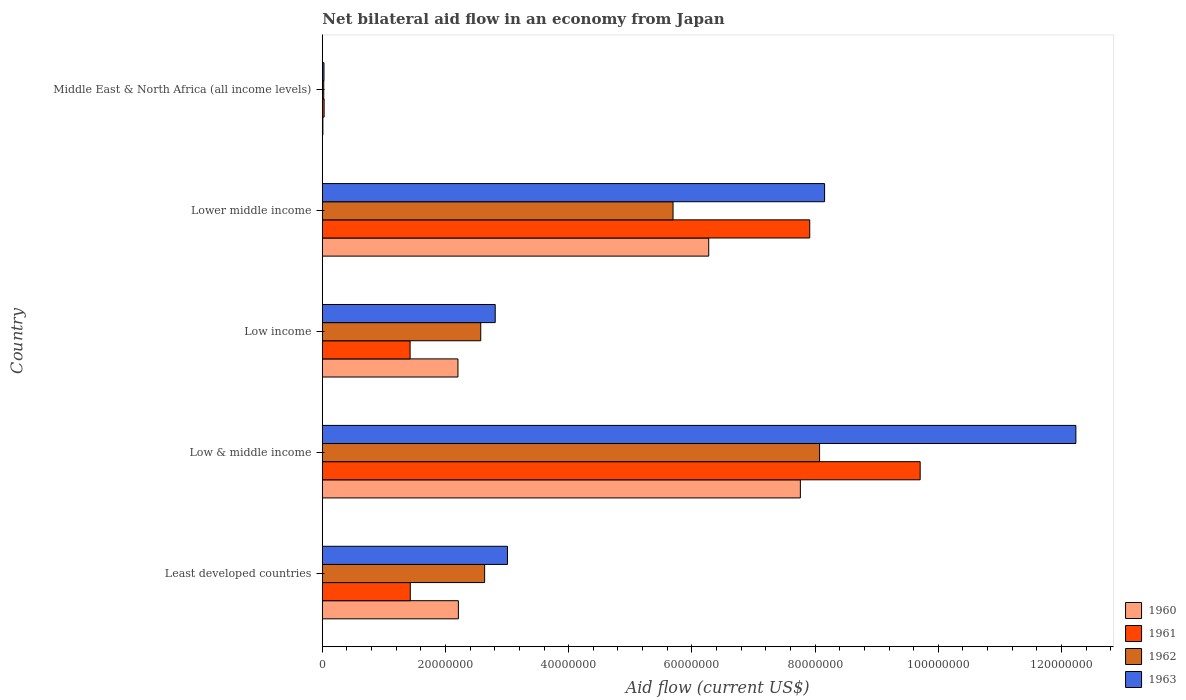How many bars are there on the 4th tick from the top?
Offer a terse response. 4. How many bars are there on the 4th tick from the bottom?
Your response must be concise. 4. What is the label of the 1st group of bars from the top?
Provide a succinct answer. Middle East & North Africa (all income levels). In how many cases, is the number of bars for a given country not equal to the number of legend labels?
Keep it short and to the point. 0. What is the net bilateral aid flow in 1962 in Low & middle income?
Provide a short and direct response. 8.07e+07. Across all countries, what is the maximum net bilateral aid flow in 1960?
Give a very brief answer. 7.76e+07. Across all countries, what is the minimum net bilateral aid flow in 1960?
Make the answer very short. 9.00e+04. In which country was the net bilateral aid flow in 1962 minimum?
Give a very brief answer. Middle East & North Africa (all income levels). What is the total net bilateral aid flow in 1960 in the graph?
Your answer should be very brief. 1.85e+08. What is the difference between the net bilateral aid flow in 1960 in Least developed countries and that in Low & middle income?
Offer a very short reply. -5.55e+07. What is the difference between the net bilateral aid flow in 1961 in Least developed countries and the net bilateral aid flow in 1963 in Low & middle income?
Offer a terse response. -1.08e+08. What is the average net bilateral aid flow in 1960 per country?
Ensure brevity in your answer.  3.69e+07. What is the difference between the net bilateral aid flow in 1963 and net bilateral aid flow in 1960 in Middle East & North Africa (all income levels)?
Your answer should be very brief. 1.80e+05. In how many countries, is the net bilateral aid flow in 1960 greater than 56000000 US$?
Keep it short and to the point. 2. What is the ratio of the net bilateral aid flow in 1960 in Low & middle income to that in Middle East & North Africa (all income levels)?
Offer a terse response. 862.33. Is the net bilateral aid flow in 1962 in Least developed countries less than that in Middle East & North Africa (all income levels)?
Offer a very short reply. No. Is the difference between the net bilateral aid flow in 1963 in Low income and Lower middle income greater than the difference between the net bilateral aid flow in 1960 in Low income and Lower middle income?
Your answer should be very brief. No. What is the difference between the highest and the second highest net bilateral aid flow in 1962?
Your answer should be very brief. 2.38e+07. What is the difference between the highest and the lowest net bilateral aid flow in 1962?
Offer a terse response. 8.05e+07. Is the sum of the net bilateral aid flow in 1961 in Least developed countries and Low income greater than the maximum net bilateral aid flow in 1962 across all countries?
Provide a short and direct response. No. What does the 1st bar from the top in Least developed countries represents?
Your answer should be compact. 1963. What does the 2nd bar from the bottom in Middle East & North Africa (all income levels) represents?
Keep it short and to the point. 1961. How many bars are there?
Your answer should be compact. 20. How many countries are there in the graph?
Provide a short and direct response. 5. What is the difference between two consecutive major ticks on the X-axis?
Give a very brief answer. 2.00e+07. Are the values on the major ticks of X-axis written in scientific E-notation?
Offer a very short reply. No. Does the graph contain any zero values?
Provide a succinct answer. No. Does the graph contain grids?
Offer a very short reply. No. Where does the legend appear in the graph?
Keep it short and to the point. Bottom right. How many legend labels are there?
Give a very brief answer. 4. What is the title of the graph?
Provide a short and direct response. Net bilateral aid flow in an economy from Japan. Does "1970" appear as one of the legend labels in the graph?
Offer a very short reply. No. What is the label or title of the X-axis?
Your answer should be compact. Aid flow (current US$). What is the Aid flow (current US$) of 1960 in Least developed countries?
Make the answer very short. 2.21e+07. What is the Aid flow (current US$) of 1961 in Least developed countries?
Your response must be concise. 1.43e+07. What is the Aid flow (current US$) in 1962 in Least developed countries?
Give a very brief answer. 2.64e+07. What is the Aid flow (current US$) in 1963 in Least developed countries?
Give a very brief answer. 3.01e+07. What is the Aid flow (current US$) in 1960 in Low & middle income?
Ensure brevity in your answer.  7.76e+07. What is the Aid flow (current US$) of 1961 in Low & middle income?
Offer a terse response. 9.71e+07. What is the Aid flow (current US$) in 1962 in Low & middle income?
Your answer should be very brief. 8.07e+07. What is the Aid flow (current US$) in 1963 in Low & middle income?
Make the answer very short. 1.22e+08. What is the Aid flow (current US$) in 1960 in Low income?
Your response must be concise. 2.20e+07. What is the Aid flow (current US$) of 1961 in Low income?
Ensure brevity in your answer.  1.42e+07. What is the Aid flow (current US$) in 1962 in Low income?
Make the answer very short. 2.57e+07. What is the Aid flow (current US$) in 1963 in Low income?
Your answer should be compact. 2.81e+07. What is the Aid flow (current US$) of 1960 in Lower middle income?
Your response must be concise. 6.27e+07. What is the Aid flow (current US$) in 1961 in Lower middle income?
Offer a terse response. 7.91e+07. What is the Aid flow (current US$) of 1962 in Lower middle income?
Your answer should be very brief. 5.69e+07. What is the Aid flow (current US$) in 1963 in Lower middle income?
Give a very brief answer. 8.15e+07. What is the Aid flow (current US$) in 1962 in Middle East & North Africa (all income levels)?
Your answer should be compact. 2.30e+05. Across all countries, what is the maximum Aid flow (current US$) in 1960?
Offer a terse response. 7.76e+07. Across all countries, what is the maximum Aid flow (current US$) of 1961?
Provide a succinct answer. 9.71e+07. Across all countries, what is the maximum Aid flow (current US$) in 1962?
Keep it short and to the point. 8.07e+07. Across all countries, what is the maximum Aid flow (current US$) of 1963?
Ensure brevity in your answer.  1.22e+08. Across all countries, what is the minimum Aid flow (current US$) in 1960?
Provide a succinct answer. 9.00e+04. Across all countries, what is the minimum Aid flow (current US$) in 1961?
Your answer should be compact. 2.90e+05. Across all countries, what is the minimum Aid flow (current US$) in 1962?
Offer a terse response. 2.30e+05. What is the total Aid flow (current US$) of 1960 in the graph?
Make the answer very short. 1.85e+08. What is the total Aid flow (current US$) in 1961 in the graph?
Offer a terse response. 2.05e+08. What is the total Aid flow (current US$) of 1962 in the graph?
Offer a terse response. 1.90e+08. What is the total Aid flow (current US$) in 1963 in the graph?
Give a very brief answer. 2.62e+08. What is the difference between the Aid flow (current US$) of 1960 in Least developed countries and that in Low & middle income?
Your answer should be very brief. -5.55e+07. What is the difference between the Aid flow (current US$) in 1961 in Least developed countries and that in Low & middle income?
Your response must be concise. -8.28e+07. What is the difference between the Aid flow (current US$) in 1962 in Least developed countries and that in Low & middle income?
Your answer should be compact. -5.44e+07. What is the difference between the Aid flow (current US$) of 1963 in Least developed countries and that in Low & middle income?
Offer a very short reply. -9.23e+07. What is the difference between the Aid flow (current US$) of 1962 in Least developed countries and that in Low income?
Keep it short and to the point. 6.30e+05. What is the difference between the Aid flow (current US$) in 1963 in Least developed countries and that in Low income?
Offer a very short reply. 1.99e+06. What is the difference between the Aid flow (current US$) of 1960 in Least developed countries and that in Lower middle income?
Offer a terse response. -4.06e+07. What is the difference between the Aid flow (current US$) in 1961 in Least developed countries and that in Lower middle income?
Provide a succinct answer. -6.48e+07. What is the difference between the Aid flow (current US$) in 1962 in Least developed countries and that in Lower middle income?
Give a very brief answer. -3.06e+07. What is the difference between the Aid flow (current US$) in 1963 in Least developed countries and that in Lower middle income?
Ensure brevity in your answer.  -5.15e+07. What is the difference between the Aid flow (current US$) of 1960 in Least developed countries and that in Middle East & North Africa (all income levels)?
Offer a very short reply. 2.20e+07. What is the difference between the Aid flow (current US$) of 1961 in Least developed countries and that in Middle East & North Africa (all income levels)?
Give a very brief answer. 1.40e+07. What is the difference between the Aid flow (current US$) in 1962 in Least developed countries and that in Middle East & North Africa (all income levels)?
Your response must be concise. 2.61e+07. What is the difference between the Aid flow (current US$) in 1963 in Least developed countries and that in Middle East & North Africa (all income levels)?
Your response must be concise. 2.98e+07. What is the difference between the Aid flow (current US$) in 1960 in Low & middle income and that in Low income?
Provide a succinct answer. 5.56e+07. What is the difference between the Aid flow (current US$) in 1961 in Low & middle income and that in Low income?
Make the answer very short. 8.28e+07. What is the difference between the Aid flow (current US$) in 1962 in Low & middle income and that in Low income?
Provide a succinct answer. 5.50e+07. What is the difference between the Aid flow (current US$) in 1963 in Low & middle income and that in Low income?
Your response must be concise. 9.43e+07. What is the difference between the Aid flow (current US$) of 1960 in Low & middle income and that in Lower middle income?
Offer a terse response. 1.49e+07. What is the difference between the Aid flow (current US$) of 1961 in Low & middle income and that in Lower middle income?
Provide a short and direct response. 1.79e+07. What is the difference between the Aid flow (current US$) of 1962 in Low & middle income and that in Lower middle income?
Your response must be concise. 2.38e+07. What is the difference between the Aid flow (current US$) in 1963 in Low & middle income and that in Lower middle income?
Keep it short and to the point. 4.08e+07. What is the difference between the Aid flow (current US$) in 1960 in Low & middle income and that in Middle East & North Africa (all income levels)?
Provide a succinct answer. 7.75e+07. What is the difference between the Aid flow (current US$) in 1961 in Low & middle income and that in Middle East & North Africa (all income levels)?
Ensure brevity in your answer.  9.68e+07. What is the difference between the Aid flow (current US$) of 1962 in Low & middle income and that in Middle East & North Africa (all income levels)?
Provide a short and direct response. 8.05e+07. What is the difference between the Aid flow (current US$) in 1963 in Low & middle income and that in Middle East & North Africa (all income levels)?
Your response must be concise. 1.22e+08. What is the difference between the Aid flow (current US$) of 1960 in Low income and that in Lower middle income?
Your answer should be very brief. -4.07e+07. What is the difference between the Aid flow (current US$) of 1961 in Low income and that in Lower middle income?
Your response must be concise. -6.49e+07. What is the difference between the Aid flow (current US$) in 1962 in Low income and that in Lower middle income?
Make the answer very short. -3.12e+07. What is the difference between the Aid flow (current US$) in 1963 in Low income and that in Lower middle income?
Offer a very short reply. -5.35e+07. What is the difference between the Aid flow (current US$) of 1960 in Low income and that in Middle East & North Africa (all income levels)?
Keep it short and to the point. 2.19e+07. What is the difference between the Aid flow (current US$) of 1961 in Low income and that in Middle East & North Africa (all income levels)?
Make the answer very short. 1.40e+07. What is the difference between the Aid flow (current US$) of 1962 in Low income and that in Middle East & North Africa (all income levels)?
Give a very brief answer. 2.55e+07. What is the difference between the Aid flow (current US$) in 1963 in Low income and that in Middle East & North Africa (all income levels)?
Provide a succinct answer. 2.78e+07. What is the difference between the Aid flow (current US$) of 1960 in Lower middle income and that in Middle East & North Africa (all income levels)?
Give a very brief answer. 6.26e+07. What is the difference between the Aid flow (current US$) of 1961 in Lower middle income and that in Middle East & North Africa (all income levels)?
Offer a terse response. 7.88e+07. What is the difference between the Aid flow (current US$) in 1962 in Lower middle income and that in Middle East & North Africa (all income levels)?
Your response must be concise. 5.67e+07. What is the difference between the Aid flow (current US$) in 1963 in Lower middle income and that in Middle East & North Africa (all income levels)?
Provide a short and direct response. 8.13e+07. What is the difference between the Aid flow (current US$) in 1960 in Least developed countries and the Aid flow (current US$) in 1961 in Low & middle income?
Provide a short and direct response. -7.50e+07. What is the difference between the Aid flow (current US$) in 1960 in Least developed countries and the Aid flow (current US$) in 1962 in Low & middle income?
Offer a very short reply. -5.86e+07. What is the difference between the Aid flow (current US$) in 1960 in Least developed countries and the Aid flow (current US$) in 1963 in Low & middle income?
Provide a short and direct response. -1.00e+08. What is the difference between the Aid flow (current US$) of 1961 in Least developed countries and the Aid flow (current US$) of 1962 in Low & middle income?
Keep it short and to the point. -6.64e+07. What is the difference between the Aid flow (current US$) in 1961 in Least developed countries and the Aid flow (current US$) in 1963 in Low & middle income?
Ensure brevity in your answer.  -1.08e+08. What is the difference between the Aid flow (current US$) in 1962 in Least developed countries and the Aid flow (current US$) in 1963 in Low & middle income?
Give a very brief answer. -9.60e+07. What is the difference between the Aid flow (current US$) in 1960 in Least developed countries and the Aid flow (current US$) in 1961 in Low income?
Provide a short and direct response. 7.84e+06. What is the difference between the Aid flow (current US$) of 1960 in Least developed countries and the Aid flow (current US$) of 1962 in Low income?
Give a very brief answer. -3.63e+06. What is the difference between the Aid flow (current US$) of 1960 in Least developed countries and the Aid flow (current US$) of 1963 in Low income?
Your answer should be compact. -5.98e+06. What is the difference between the Aid flow (current US$) in 1961 in Least developed countries and the Aid flow (current US$) in 1962 in Low income?
Your answer should be very brief. -1.14e+07. What is the difference between the Aid flow (current US$) of 1961 in Least developed countries and the Aid flow (current US$) of 1963 in Low income?
Provide a succinct answer. -1.38e+07. What is the difference between the Aid flow (current US$) of 1962 in Least developed countries and the Aid flow (current US$) of 1963 in Low income?
Your response must be concise. -1.72e+06. What is the difference between the Aid flow (current US$) in 1960 in Least developed countries and the Aid flow (current US$) in 1961 in Lower middle income?
Your answer should be very brief. -5.70e+07. What is the difference between the Aid flow (current US$) of 1960 in Least developed countries and the Aid flow (current US$) of 1962 in Lower middle income?
Make the answer very short. -3.48e+07. What is the difference between the Aid flow (current US$) in 1960 in Least developed countries and the Aid flow (current US$) in 1963 in Lower middle income?
Provide a short and direct response. -5.94e+07. What is the difference between the Aid flow (current US$) of 1961 in Least developed countries and the Aid flow (current US$) of 1962 in Lower middle income?
Give a very brief answer. -4.27e+07. What is the difference between the Aid flow (current US$) in 1961 in Least developed countries and the Aid flow (current US$) in 1963 in Lower middle income?
Your response must be concise. -6.73e+07. What is the difference between the Aid flow (current US$) of 1962 in Least developed countries and the Aid flow (current US$) of 1963 in Lower middle income?
Your answer should be very brief. -5.52e+07. What is the difference between the Aid flow (current US$) of 1960 in Least developed countries and the Aid flow (current US$) of 1961 in Middle East & North Africa (all income levels)?
Offer a very short reply. 2.18e+07. What is the difference between the Aid flow (current US$) in 1960 in Least developed countries and the Aid flow (current US$) in 1962 in Middle East & North Africa (all income levels)?
Your answer should be very brief. 2.19e+07. What is the difference between the Aid flow (current US$) in 1960 in Least developed countries and the Aid flow (current US$) in 1963 in Middle East & North Africa (all income levels)?
Your answer should be compact. 2.18e+07. What is the difference between the Aid flow (current US$) of 1961 in Least developed countries and the Aid flow (current US$) of 1962 in Middle East & North Africa (all income levels)?
Your response must be concise. 1.40e+07. What is the difference between the Aid flow (current US$) of 1961 in Least developed countries and the Aid flow (current US$) of 1963 in Middle East & North Africa (all income levels)?
Your answer should be very brief. 1.40e+07. What is the difference between the Aid flow (current US$) of 1962 in Least developed countries and the Aid flow (current US$) of 1963 in Middle East & North Africa (all income levels)?
Your answer should be compact. 2.61e+07. What is the difference between the Aid flow (current US$) of 1960 in Low & middle income and the Aid flow (current US$) of 1961 in Low income?
Your answer should be very brief. 6.34e+07. What is the difference between the Aid flow (current US$) of 1960 in Low & middle income and the Aid flow (current US$) of 1962 in Low income?
Provide a succinct answer. 5.19e+07. What is the difference between the Aid flow (current US$) of 1960 in Low & middle income and the Aid flow (current US$) of 1963 in Low income?
Offer a terse response. 4.95e+07. What is the difference between the Aid flow (current US$) of 1961 in Low & middle income and the Aid flow (current US$) of 1962 in Low income?
Keep it short and to the point. 7.13e+07. What is the difference between the Aid flow (current US$) of 1961 in Low & middle income and the Aid flow (current US$) of 1963 in Low income?
Provide a short and direct response. 6.90e+07. What is the difference between the Aid flow (current US$) of 1962 in Low & middle income and the Aid flow (current US$) of 1963 in Low income?
Your response must be concise. 5.27e+07. What is the difference between the Aid flow (current US$) in 1960 in Low & middle income and the Aid flow (current US$) in 1961 in Lower middle income?
Your answer should be very brief. -1.52e+06. What is the difference between the Aid flow (current US$) of 1960 in Low & middle income and the Aid flow (current US$) of 1962 in Lower middle income?
Offer a terse response. 2.07e+07. What is the difference between the Aid flow (current US$) of 1960 in Low & middle income and the Aid flow (current US$) of 1963 in Lower middle income?
Keep it short and to the point. -3.93e+06. What is the difference between the Aid flow (current US$) in 1961 in Low & middle income and the Aid flow (current US$) in 1962 in Lower middle income?
Your response must be concise. 4.01e+07. What is the difference between the Aid flow (current US$) of 1961 in Low & middle income and the Aid flow (current US$) of 1963 in Lower middle income?
Offer a very short reply. 1.55e+07. What is the difference between the Aid flow (current US$) of 1962 in Low & middle income and the Aid flow (current US$) of 1963 in Lower middle income?
Make the answer very short. -8.10e+05. What is the difference between the Aid flow (current US$) in 1960 in Low & middle income and the Aid flow (current US$) in 1961 in Middle East & North Africa (all income levels)?
Provide a succinct answer. 7.73e+07. What is the difference between the Aid flow (current US$) in 1960 in Low & middle income and the Aid flow (current US$) in 1962 in Middle East & North Africa (all income levels)?
Make the answer very short. 7.74e+07. What is the difference between the Aid flow (current US$) of 1960 in Low & middle income and the Aid flow (current US$) of 1963 in Middle East & North Africa (all income levels)?
Keep it short and to the point. 7.73e+07. What is the difference between the Aid flow (current US$) of 1961 in Low & middle income and the Aid flow (current US$) of 1962 in Middle East & North Africa (all income levels)?
Your answer should be very brief. 9.68e+07. What is the difference between the Aid flow (current US$) of 1961 in Low & middle income and the Aid flow (current US$) of 1963 in Middle East & North Africa (all income levels)?
Make the answer very short. 9.68e+07. What is the difference between the Aid flow (current US$) in 1962 in Low & middle income and the Aid flow (current US$) in 1963 in Middle East & North Africa (all income levels)?
Ensure brevity in your answer.  8.05e+07. What is the difference between the Aid flow (current US$) of 1960 in Low income and the Aid flow (current US$) of 1961 in Lower middle income?
Keep it short and to the point. -5.71e+07. What is the difference between the Aid flow (current US$) of 1960 in Low income and the Aid flow (current US$) of 1962 in Lower middle income?
Make the answer very short. -3.49e+07. What is the difference between the Aid flow (current US$) in 1960 in Low income and the Aid flow (current US$) in 1963 in Lower middle income?
Provide a short and direct response. -5.95e+07. What is the difference between the Aid flow (current US$) in 1961 in Low income and the Aid flow (current US$) in 1962 in Lower middle income?
Your answer should be very brief. -4.27e+07. What is the difference between the Aid flow (current US$) in 1961 in Low income and the Aid flow (current US$) in 1963 in Lower middle income?
Offer a very short reply. -6.73e+07. What is the difference between the Aid flow (current US$) of 1962 in Low income and the Aid flow (current US$) of 1963 in Lower middle income?
Your answer should be compact. -5.58e+07. What is the difference between the Aid flow (current US$) in 1960 in Low income and the Aid flow (current US$) in 1961 in Middle East & North Africa (all income levels)?
Give a very brief answer. 2.17e+07. What is the difference between the Aid flow (current US$) in 1960 in Low income and the Aid flow (current US$) in 1962 in Middle East & North Africa (all income levels)?
Give a very brief answer. 2.18e+07. What is the difference between the Aid flow (current US$) of 1960 in Low income and the Aid flow (current US$) of 1963 in Middle East & North Africa (all income levels)?
Your answer should be very brief. 2.18e+07. What is the difference between the Aid flow (current US$) in 1961 in Low income and the Aid flow (current US$) in 1962 in Middle East & North Africa (all income levels)?
Make the answer very short. 1.40e+07. What is the difference between the Aid flow (current US$) of 1961 in Low income and the Aid flow (current US$) of 1963 in Middle East & North Africa (all income levels)?
Your answer should be compact. 1.40e+07. What is the difference between the Aid flow (current US$) in 1962 in Low income and the Aid flow (current US$) in 1963 in Middle East & North Africa (all income levels)?
Your answer should be very brief. 2.54e+07. What is the difference between the Aid flow (current US$) of 1960 in Lower middle income and the Aid flow (current US$) of 1961 in Middle East & North Africa (all income levels)?
Provide a succinct answer. 6.24e+07. What is the difference between the Aid flow (current US$) in 1960 in Lower middle income and the Aid flow (current US$) in 1962 in Middle East & North Africa (all income levels)?
Offer a terse response. 6.25e+07. What is the difference between the Aid flow (current US$) in 1960 in Lower middle income and the Aid flow (current US$) in 1963 in Middle East & North Africa (all income levels)?
Offer a very short reply. 6.25e+07. What is the difference between the Aid flow (current US$) in 1961 in Lower middle income and the Aid flow (current US$) in 1962 in Middle East & North Africa (all income levels)?
Keep it short and to the point. 7.89e+07. What is the difference between the Aid flow (current US$) of 1961 in Lower middle income and the Aid flow (current US$) of 1963 in Middle East & North Africa (all income levels)?
Your answer should be compact. 7.89e+07. What is the difference between the Aid flow (current US$) of 1962 in Lower middle income and the Aid flow (current US$) of 1963 in Middle East & North Africa (all income levels)?
Your answer should be compact. 5.67e+07. What is the average Aid flow (current US$) in 1960 per country?
Give a very brief answer. 3.69e+07. What is the average Aid flow (current US$) in 1961 per country?
Make the answer very short. 4.10e+07. What is the average Aid flow (current US$) in 1962 per country?
Keep it short and to the point. 3.80e+07. What is the average Aid flow (current US$) of 1963 per country?
Offer a terse response. 5.25e+07. What is the difference between the Aid flow (current US$) in 1960 and Aid flow (current US$) in 1961 in Least developed countries?
Provide a succinct answer. 7.81e+06. What is the difference between the Aid flow (current US$) of 1960 and Aid flow (current US$) of 1962 in Least developed countries?
Offer a terse response. -4.26e+06. What is the difference between the Aid flow (current US$) of 1960 and Aid flow (current US$) of 1963 in Least developed countries?
Make the answer very short. -7.97e+06. What is the difference between the Aid flow (current US$) of 1961 and Aid flow (current US$) of 1962 in Least developed countries?
Provide a short and direct response. -1.21e+07. What is the difference between the Aid flow (current US$) of 1961 and Aid flow (current US$) of 1963 in Least developed countries?
Keep it short and to the point. -1.58e+07. What is the difference between the Aid flow (current US$) of 1962 and Aid flow (current US$) of 1963 in Least developed countries?
Your response must be concise. -3.71e+06. What is the difference between the Aid flow (current US$) in 1960 and Aid flow (current US$) in 1961 in Low & middle income?
Provide a short and direct response. -1.94e+07. What is the difference between the Aid flow (current US$) in 1960 and Aid flow (current US$) in 1962 in Low & middle income?
Provide a short and direct response. -3.12e+06. What is the difference between the Aid flow (current US$) in 1960 and Aid flow (current US$) in 1963 in Low & middle income?
Provide a succinct answer. -4.47e+07. What is the difference between the Aid flow (current US$) in 1961 and Aid flow (current US$) in 1962 in Low & middle income?
Provide a succinct answer. 1.63e+07. What is the difference between the Aid flow (current US$) of 1961 and Aid flow (current US$) of 1963 in Low & middle income?
Provide a succinct answer. -2.53e+07. What is the difference between the Aid flow (current US$) in 1962 and Aid flow (current US$) in 1963 in Low & middle income?
Your response must be concise. -4.16e+07. What is the difference between the Aid flow (current US$) in 1960 and Aid flow (current US$) in 1961 in Low income?
Give a very brief answer. 7.77e+06. What is the difference between the Aid flow (current US$) of 1960 and Aid flow (current US$) of 1962 in Low income?
Ensure brevity in your answer.  -3.70e+06. What is the difference between the Aid flow (current US$) in 1960 and Aid flow (current US$) in 1963 in Low income?
Your answer should be compact. -6.05e+06. What is the difference between the Aid flow (current US$) in 1961 and Aid flow (current US$) in 1962 in Low income?
Offer a terse response. -1.15e+07. What is the difference between the Aid flow (current US$) in 1961 and Aid flow (current US$) in 1963 in Low income?
Your answer should be very brief. -1.38e+07. What is the difference between the Aid flow (current US$) in 1962 and Aid flow (current US$) in 1963 in Low income?
Ensure brevity in your answer.  -2.35e+06. What is the difference between the Aid flow (current US$) of 1960 and Aid flow (current US$) of 1961 in Lower middle income?
Provide a succinct answer. -1.64e+07. What is the difference between the Aid flow (current US$) in 1960 and Aid flow (current US$) in 1962 in Lower middle income?
Make the answer very short. 5.79e+06. What is the difference between the Aid flow (current US$) in 1960 and Aid flow (current US$) in 1963 in Lower middle income?
Ensure brevity in your answer.  -1.88e+07. What is the difference between the Aid flow (current US$) of 1961 and Aid flow (current US$) of 1962 in Lower middle income?
Your answer should be compact. 2.22e+07. What is the difference between the Aid flow (current US$) in 1961 and Aid flow (current US$) in 1963 in Lower middle income?
Offer a terse response. -2.41e+06. What is the difference between the Aid flow (current US$) of 1962 and Aid flow (current US$) of 1963 in Lower middle income?
Provide a short and direct response. -2.46e+07. What is the difference between the Aid flow (current US$) in 1960 and Aid flow (current US$) in 1961 in Middle East & North Africa (all income levels)?
Offer a very short reply. -2.00e+05. What is the difference between the Aid flow (current US$) of 1960 and Aid flow (current US$) of 1962 in Middle East & North Africa (all income levels)?
Ensure brevity in your answer.  -1.40e+05. What is the difference between the Aid flow (current US$) of 1961 and Aid flow (current US$) of 1962 in Middle East & North Africa (all income levels)?
Ensure brevity in your answer.  6.00e+04. What is the difference between the Aid flow (current US$) of 1961 and Aid flow (current US$) of 1963 in Middle East & North Africa (all income levels)?
Your answer should be compact. 2.00e+04. What is the difference between the Aid flow (current US$) of 1962 and Aid flow (current US$) of 1963 in Middle East & North Africa (all income levels)?
Keep it short and to the point. -4.00e+04. What is the ratio of the Aid flow (current US$) of 1960 in Least developed countries to that in Low & middle income?
Offer a terse response. 0.28. What is the ratio of the Aid flow (current US$) of 1961 in Least developed countries to that in Low & middle income?
Offer a terse response. 0.15. What is the ratio of the Aid flow (current US$) in 1962 in Least developed countries to that in Low & middle income?
Give a very brief answer. 0.33. What is the ratio of the Aid flow (current US$) in 1963 in Least developed countries to that in Low & middle income?
Offer a terse response. 0.25. What is the ratio of the Aid flow (current US$) of 1960 in Least developed countries to that in Low income?
Your answer should be compact. 1. What is the ratio of the Aid flow (current US$) of 1962 in Least developed countries to that in Low income?
Your answer should be very brief. 1.02. What is the ratio of the Aid flow (current US$) in 1963 in Least developed countries to that in Low income?
Provide a short and direct response. 1.07. What is the ratio of the Aid flow (current US$) in 1960 in Least developed countries to that in Lower middle income?
Make the answer very short. 0.35. What is the ratio of the Aid flow (current US$) of 1961 in Least developed countries to that in Lower middle income?
Make the answer very short. 0.18. What is the ratio of the Aid flow (current US$) in 1962 in Least developed countries to that in Lower middle income?
Provide a succinct answer. 0.46. What is the ratio of the Aid flow (current US$) of 1963 in Least developed countries to that in Lower middle income?
Give a very brief answer. 0.37. What is the ratio of the Aid flow (current US$) of 1960 in Least developed countries to that in Middle East & North Africa (all income levels)?
Offer a terse response. 245.44. What is the ratio of the Aid flow (current US$) in 1961 in Least developed countries to that in Middle East & North Africa (all income levels)?
Provide a short and direct response. 49.24. What is the ratio of the Aid flow (current US$) of 1962 in Least developed countries to that in Middle East & North Africa (all income levels)?
Give a very brief answer. 114.57. What is the ratio of the Aid flow (current US$) in 1963 in Least developed countries to that in Middle East & North Africa (all income levels)?
Make the answer very short. 111.33. What is the ratio of the Aid flow (current US$) in 1960 in Low & middle income to that in Low income?
Give a very brief answer. 3.52. What is the ratio of the Aid flow (current US$) in 1961 in Low & middle income to that in Low income?
Your answer should be compact. 6.81. What is the ratio of the Aid flow (current US$) in 1962 in Low & middle income to that in Low income?
Offer a terse response. 3.14. What is the ratio of the Aid flow (current US$) of 1963 in Low & middle income to that in Low income?
Your answer should be compact. 4.36. What is the ratio of the Aid flow (current US$) of 1960 in Low & middle income to that in Lower middle income?
Your response must be concise. 1.24. What is the ratio of the Aid flow (current US$) of 1961 in Low & middle income to that in Lower middle income?
Provide a short and direct response. 1.23. What is the ratio of the Aid flow (current US$) in 1962 in Low & middle income to that in Lower middle income?
Provide a short and direct response. 1.42. What is the ratio of the Aid flow (current US$) in 1963 in Low & middle income to that in Lower middle income?
Provide a succinct answer. 1.5. What is the ratio of the Aid flow (current US$) of 1960 in Low & middle income to that in Middle East & North Africa (all income levels)?
Your answer should be very brief. 862.33. What is the ratio of the Aid flow (current US$) in 1961 in Low & middle income to that in Middle East & North Africa (all income levels)?
Give a very brief answer. 334.69. What is the ratio of the Aid flow (current US$) of 1962 in Low & middle income to that in Middle East & North Africa (all income levels)?
Provide a short and direct response. 351. What is the ratio of the Aid flow (current US$) of 1963 in Low & middle income to that in Middle East & North Africa (all income levels)?
Your response must be concise. 453.11. What is the ratio of the Aid flow (current US$) of 1960 in Low income to that in Lower middle income?
Your answer should be compact. 0.35. What is the ratio of the Aid flow (current US$) in 1961 in Low income to that in Lower middle income?
Provide a succinct answer. 0.18. What is the ratio of the Aid flow (current US$) in 1962 in Low income to that in Lower middle income?
Your answer should be very brief. 0.45. What is the ratio of the Aid flow (current US$) in 1963 in Low income to that in Lower middle income?
Give a very brief answer. 0.34. What is the ratio of the Aid flow (current US$) of 1960 in Low income to that in Middle East & North Africa (all income levels)?
Your response must be concise. 244.67. What is the ratio of the Aid flow (current US$) of 1961 in Low income to that in Middle East & North Africa (all income levels)?
Provide a succinct answer. 49.14. What is the ratio of the Aid flow (current US$) of 1962 in Low income to that in Middle East & North Africa (all income levels)?
Keep it short and to the point. 111.83. What is the ratio of the Aid flow (current US$) of 1963 in Low income to that in Middle East & North Africa (all income levels)?
Make the answer very short. 103.96. What is the ratio of the Aid flow (current US$) in 1960 in Lower middle income to that in Middle East & North Africa (all income levels)?
Your response must be concise. 697. What is the ratio of the Aid flow (current US$) in 1961 in Lower middle income to that in Middle East & North Africa (all income levels)?
Provide a short and direct response. 272.86. What is the ratio of the Aid flow (current US$) of 1962 in Lower middle income to that in Middle East & North Africa (all income levels)?
Your answer should be compact. 247.57. What is the ratio of the Aid flow (current US$) in 1963 in Lower middle income to that in Middle East & North Africa (all income levels)?
Your response must be concise. 302. What is the difference between the highest and the second highest Aid flow (current US$) of 1960?
Your response must be concise. 1.49e+07. What is the difference between the highest and the second highest Aid flow (current US$) in 1961?
Offer a terse response. 1.79e+07. What is the difference between the highest and the second highest Aid flow (current US$) of 1962?
Provide a succinct answer. 2.38e+07. What is the difference between the highest and the second highest Aid flow (current US$) in 1963?
Keep it short and to the point. 4.08e+07. What is the difference between the highest and the lowest Aid flow (current US$) in 1960?
Offer a terse response. 7.75e+07. What is the difference between the highest and the lowest Aid flow (current US$) in 1961?
Your answer should be very brief. 9.68e+07. What is the difference between the highest and the lowest Aid flow (current US$) of 1962?
Your answer should be very brief. 8.05e+07. What is the difference between the highest and the lowest Aid flow (current US$) of 1963?
Make the answer very short. 1.22e+08. 